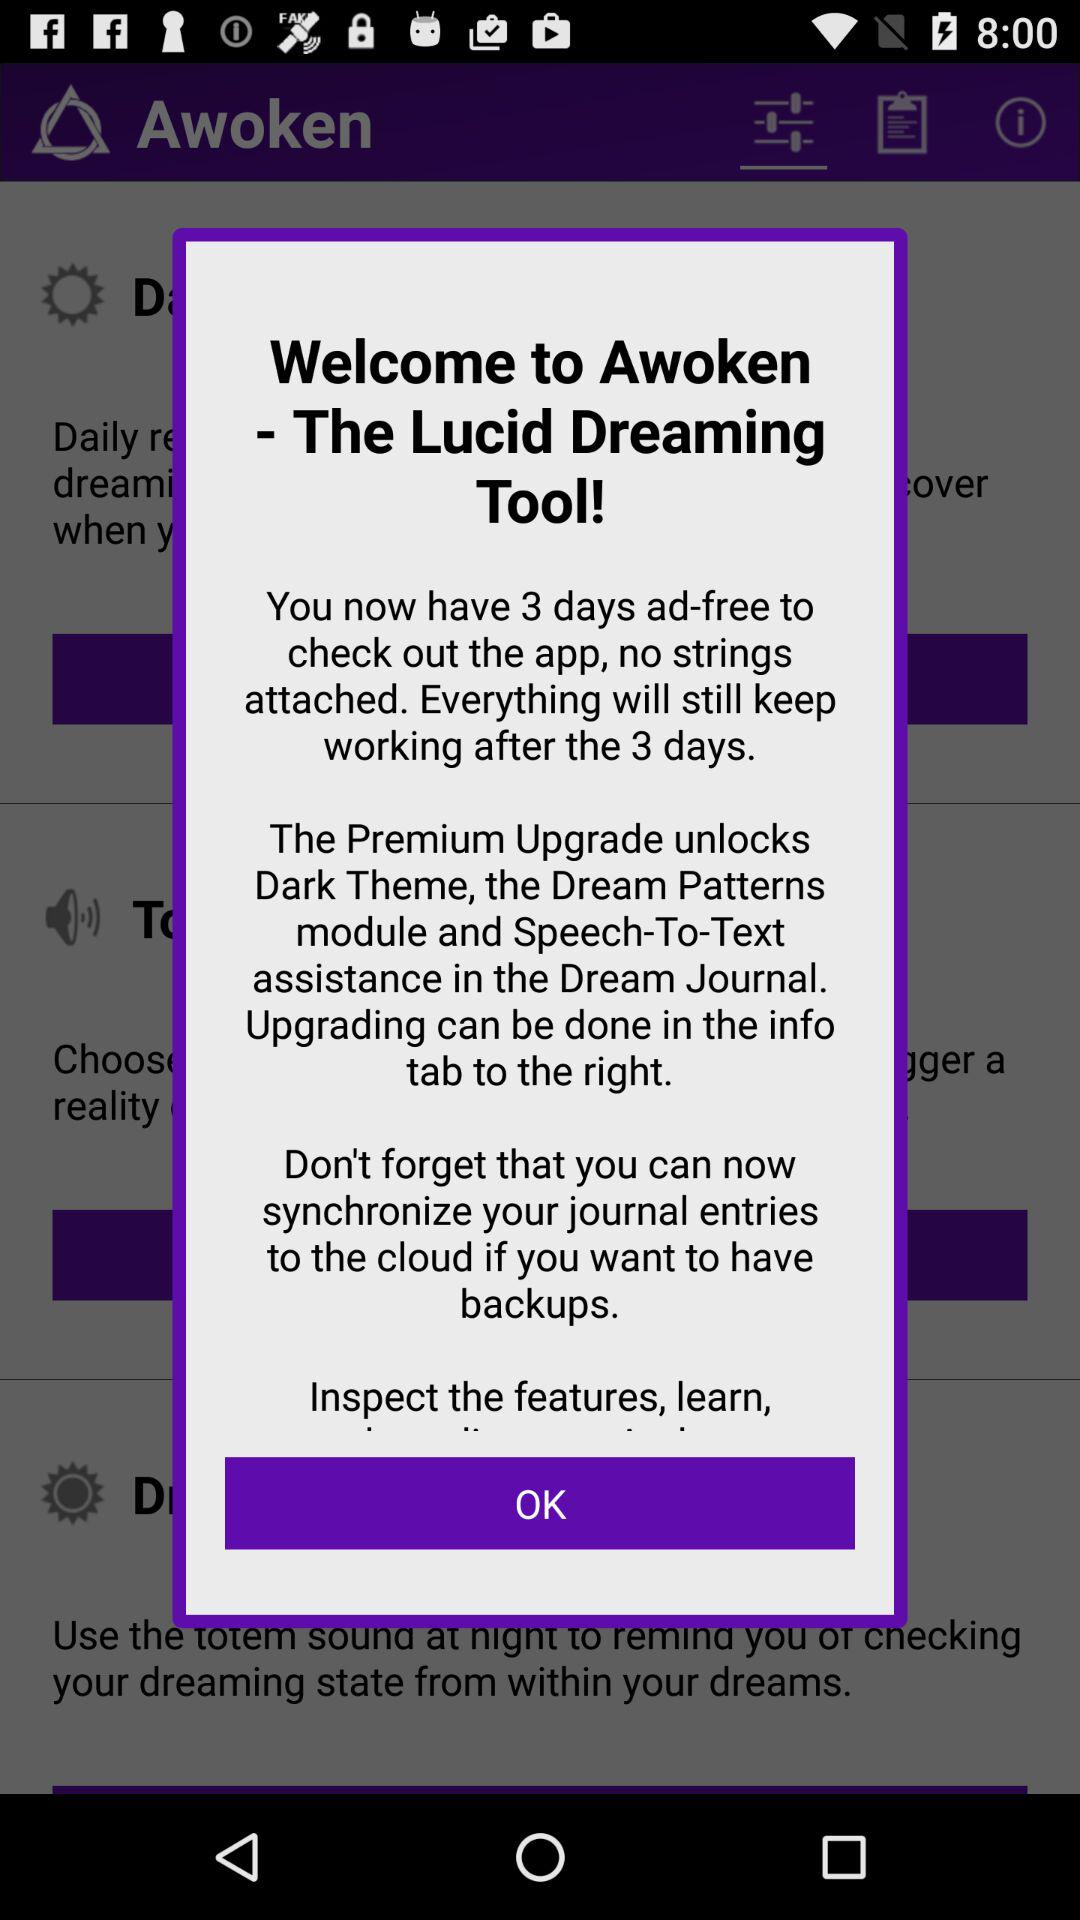How many days are left before the ad-free trial ends?
Answer the question using a single word or phrase. 3 